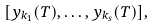Convert formula to latex. <formula><loc_0><loc_0><loc_500><loc_500>[ y _ { k _ { 1 } } ( T ) , \dots , y _ { k _ { s } } ( T ) ] ,</formula> 